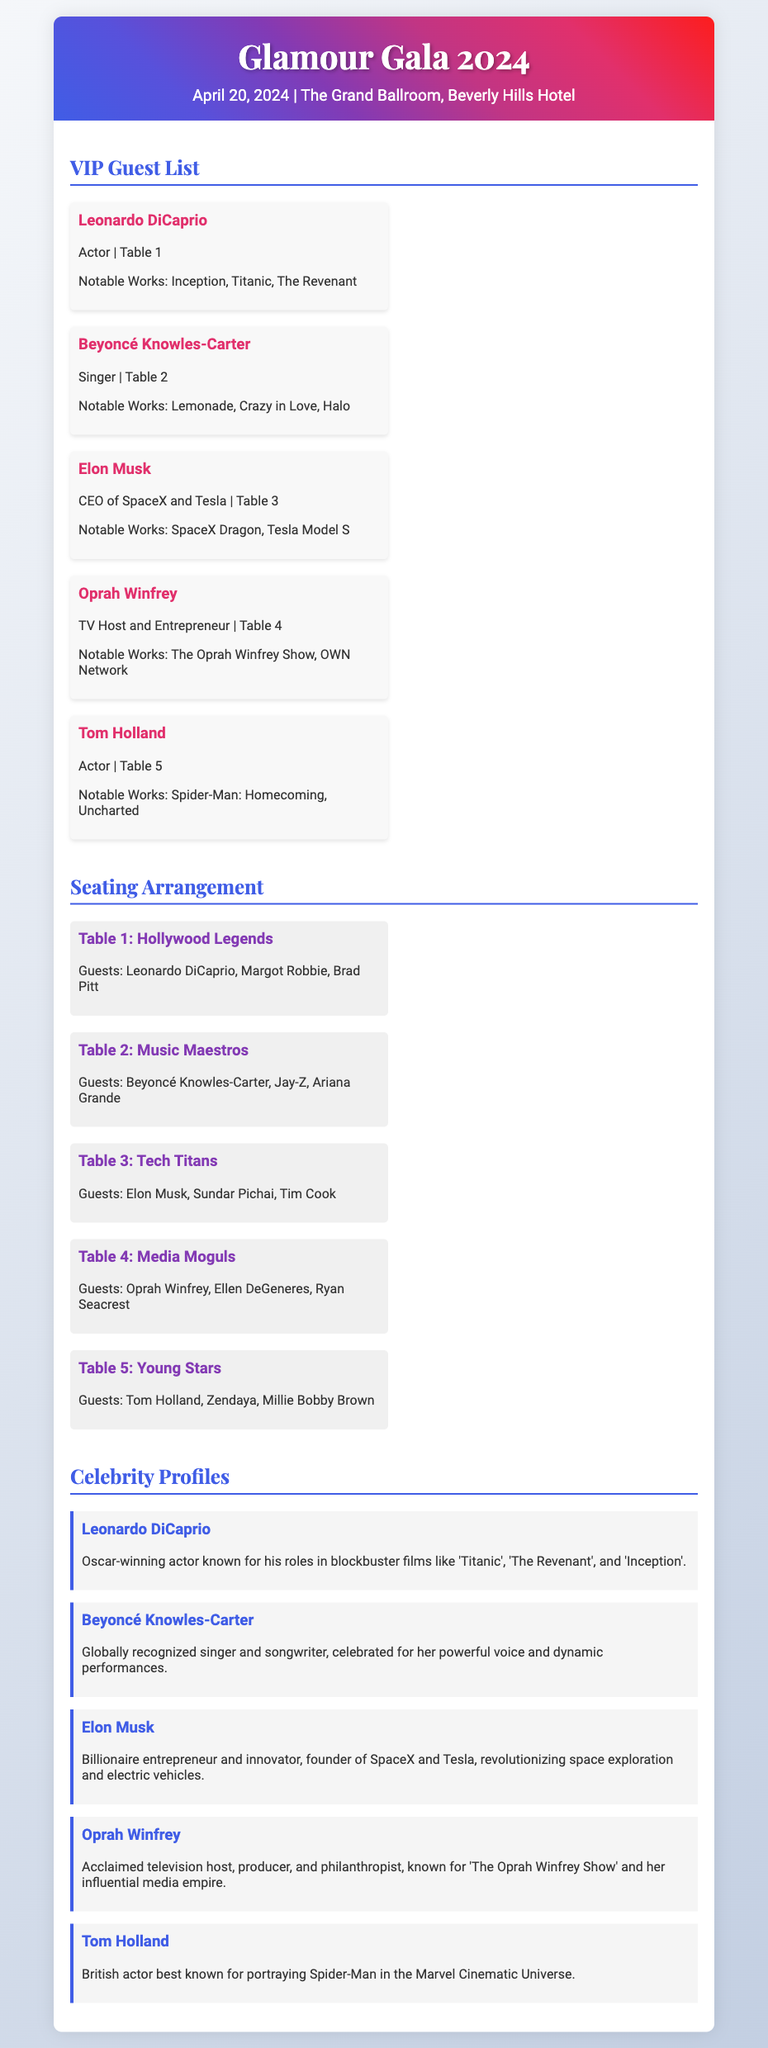What is the date of the Glamour Gala 2024? The date of the event is explicitly mentioned in the header section of the document.
Answer: April 20, 2024 Who is seated at Table 1? The document states the guests seated at each table, indicating who is at Table 1.
Answer: Leonardo DiCaprio, Margot Robbie, Brad Pitt What is the notable work of Beyoncé Knowles-Carter? The notable works section lists specific works associated with each celebrity, which applies to Beyoncé as well.
Answer: Lemonade Which table is Elon Musk assigned to? The VIP guest list provides the table assignments for each guest listed.
Answer: Table 3 How many guests are seated at Table 2? The seating arrangement specifies the number of guests at each table, allowing for a count of those at Table 2.
Answer: 3 Who is the host of "The Oprah Winfrey Show"? The celebrity profile for Oprah Winfrey explicitly states her role related to the show.
Answer: Oprah Winfrey What color is the header background? The document design specifies gradient colors in the header section, allowing for a description of its style.
Answer: Gradient from blue to purple to red What is the theme of Table 4? Each table in the seating arrangement has a theme or title indicating the type of guests; this applies to Table 4.
Answer: Media Moguls 